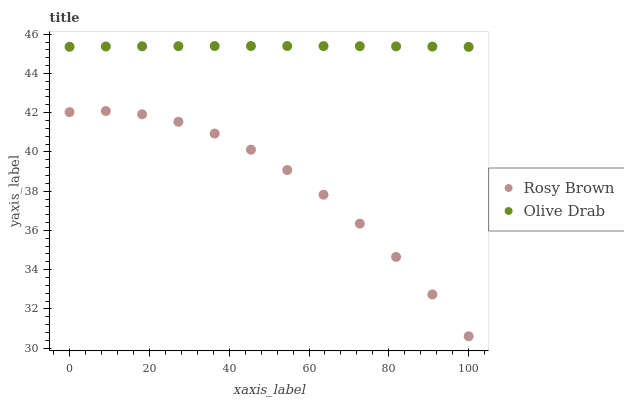Does Rosy Brown have the minimum area under the curve?
Answer yes or no. Yes. Does Olive Drab have the maximum area under the curve?
Answer yes or no. Yes. Does Olive Drab have the minimum area under the curve?
Answer yes or no. No. Is Olive Drab the smoothest?
Answer yes or no. Yes. Is Rosy Brown the roughest?
Answer yes or no. Yes. Is Olive Drab the roughest?
Answer yes or no. No. Does Rosy Brown have the lowest value?
Answer yes or no. Yes. Does Olive Drab have the lowest value?
Answer yes or no. No. Does Olive Drab have the highest value?
Answer yes or no. Yes. Is Rosy Brown less than Olive Drab?
Answer yes or no. Yes. Is Olive Drab greater than Rosy Brown?
Answer yes or no. Yes. Does Rosy Brown intersect Olive Drab?
Answer yes or no. No. 